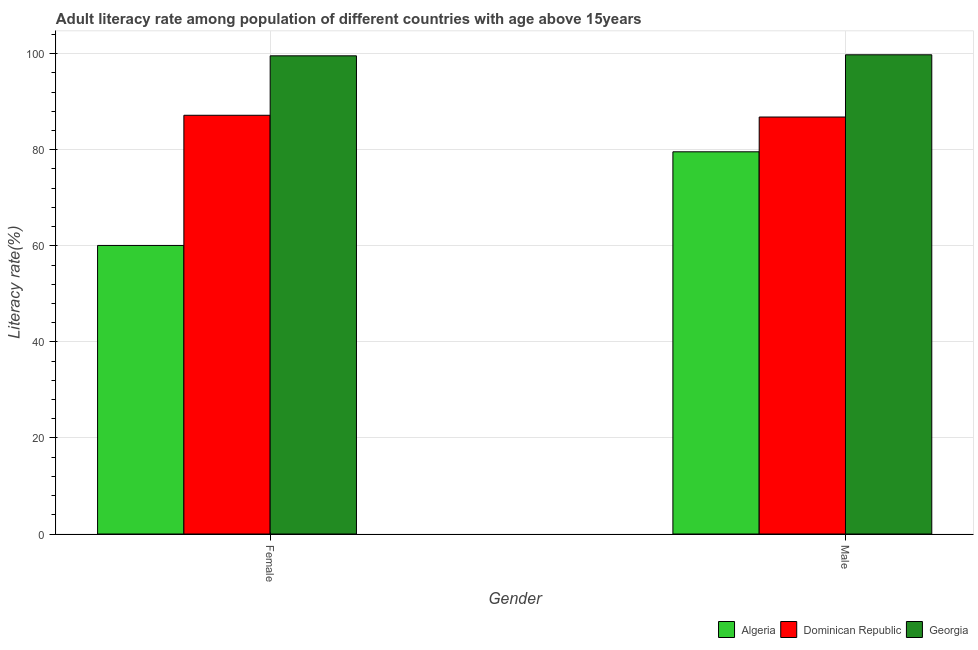How many different coloured bars are there?
Offer a terse response. 3. How many groups of bars are there?
Keep it short and to the point. 2. Are the number of bars per tick equal to the number of legend labels?
Make the answer very short. Yes. How many bars are there on the 2nd tick from the left?
Offer a very short reply. 3. How many bars are there on the 2nd tick from the right?
Keep it short and to the point. 3. What is the label of the 1st group of bars from the left?
Make the answer very short. Female. What is the male adult literacy rate in Algeria?
Make the answer very short. 79.57. Across all countries, what is the maximum female adult literacy rate?
Provide a short and direct response. 99.55. Across all countries, what is the minimum female adult literacy rate?
Your answer should be compact. 60.08. In which country was the female adult literacy rate maximum?
Keep it short and to the point. Georgia. In which country was the male adult literacy rate minimum?
Provide a short and direct response. Algeria. What is the total male adult literacy rate in the graph?
Your response must be concise. 266.15. What is the difference between the female adult literacy rate in Algeria and that in Georgia?
Offer a terse response. -39.48. What is the difference between the female adult literacy rate in Georgia and the male adult literacy rate in Algeria?
Make the answer very short. 19.98. What is the average male adult literacy rate per country?
Keep it short and to the point. 88.72. What is the difference between the male adult literacy rate and female adult literacy rate in Dominican Republic?
Keep it short and to the point. -0.37. In how many countries, is the female adult literacy rate greater than 96 %?
Your answer should be compact. 1. What is the ratio of the female adult literacy rate in Georgia to that in Dominican Republic?
Your answer should be compact. 1.14. In how many countries, is the female adult literacy rate greater than the average female adult literacy rate taken over all countries?
Your answer should be compact. 2. What does the 1st bar from the left in Female represents?
Ensure brevity in your answer.  Algeria. What does the 3rd bar from the right in Male represents?
Ensure brevity in your answer.  Algeria. How many bars are there?
Ensure brevity in your answer.  6. Does the graph contain any zero values?
Provide a succinct answer. No. Does the graph contain grids?
Provide a short and direct response. Yes. Where does the legend appear in the graph?
Your response must be concise. Bottom right. How many legend labels are there?
Keep it short and to the point. 3. What is the title of the graph?
Offer a very short reply. Adult literacy rate among population of different countries with age above 15years. What is the label or title of the X-axis?
Ensure brevity in your answer.  Gender. What is the label or title of the Y-axis?
Ensure brevity in your answer.  Literacy rate(%). What is the Literacy rate(%) of Algeria in Female?
Provide a short and direct response. 60.08. What is the Literacy rate(%) of Dominican Republic in Female?
Provide a succinct answer. 87.18. What is the Literacy rate(%) of Georgia in Female?
Your answer should be very brief. 99.55. What is the Literacy rate(%) of Algeria in Male?
Provide a succinct answer. 79.57. What is the Literacy rate(%) of Dominican Republic in Male?
Your answer should be compact. 86.81. What is the Literacy rate(%) of Georgia in Male?
Provide a succinct answer. 99.77. Across all Gender, what is the maximum Literacy rate(%) in Algeria?
Offer a very short reply. 79.57. Across all Gender, what is the maximum Literacy rate(%) of Dominican Republic?
Your response must be concise. 87.18. Across all Gender, what is the maximum Literacy rate(%) in Georgia?
Offer a terse response. 99.77. Across all Gender, what is the minimum Literacy rate(%) of Algeria?
Give a very brief answer. 60.08. Across all Gender, what is the minimum Literacy rate(%) of Dominican Republic?
Give a very brief answer. 86.81. Across all Gender, what is the minimum Literacy rate(%) of Georgia?
Ensure brevity in your answer.  99.55. What is the total Literacy rate(%) of Algeria in the graph?
Provide a short and direct response. 139.64. What is the total Literacy rate(%) in Dominican Republic in the graph?
Give a very brief answer. 173.99. What is the total Literacy rate(%) in Georgia in the graph?
Offer a very short reply. 199.32. What is the difference between the Literacy rate(%) of Algeria in Female and that in Male?
Provide a short and direct response. -19.49. What is the difference between the Literacy rate(%) of Dominican Republic in Female and that in Male?
Offer a very short reply. 0.37. What is the difference between the Literacy rate(%) of Georgia in Female and that in Male?
Give a very brief answer. -0.22. What is the difference between the Literacy rate(%) in Algeria in Female and the Literacy rate(%) in Dominican Republic in Male?
Keep it short and to the point. -26.74. What is the difference between the Literacy rate(%) in Algeria in Female and the Literacy rate(%) in Georgia in Male?
Provide a short and direct response. -39.69. What is the difference between the Literacy rate(%) in Dominican Republic in Female and the Literacy rate(%) in Georgia in Male?
Offer a terse response. -12.59. What is the average Literacy rate(%) of Algeria per Gender?
Offer a very short reply. 69.82. What is the average Literacy rate(%) of Dominican Republic per Gender?
Your answer should be very brief. 86.99. What is the average Literacy rate(%) of Georgia per Gender?
Provide a short and direct response. 99.66. What is the difference between the Literacy rate(%) in Algeria and Literacy rate(%) in Dominican Republic in Female?
Ensure brevity in your answer.  -27.1. What is the difference between the Literacy rate(%) of Algeria and Literacy rate(%) of Georgia in Female?
Your answer should be very brief. -39.48. What is the difference between the Literacy rate(%) in Dominican Republic and Literacy rate(%) in Georgia in Female?
Keep it short and to the point. -12.38. What is the difference between the Literacy rate(%) of Algeria and Literacy rate(%) of Dominican Republic in Male?
Provide a short and direct response. -7.24. What is the difference between the Literacy rate(%) of Algeria and Literacy rate(%) of Georgia in Male?
Offer a very short reply. -20.2. What is the difference between the Literacy rate(%) of Dominican Republic and Literacy rate(%) of Georgia in Male?
Your response must be concise. -12.96. What is the ratio of the Literacy rate(%) in Algeria in Female to that in Male?
Ensure brevity in your answer.  0.76. What is the ratio of the Literacy rate(%) of Georgia in Female to that in Male?
Your answer should be compact. 1. What is the difference between the highest and the second highest Literacy rate(%) of Algeria?
Offer a terse response. 19.49. What is the difference between the highest and the second highest Literacy rate(%) in Dominican Republic?
Give a very brief answer. 0.37. What is the difference between the highest and the second highest Literacy rate(%) in Georgia?
Make the answer very short. 0.22. What is the difference between the highest and the lowest Literacy rate(%) of Algeria?
Your answer should be compact. 19.49. What is the difference between the highest and the lowest Literacy rate(%) in Dominican Republic?
Keep it short and to the point. 0.37. What is the difference between the highest and the lowest Literacy rate(%) in Georgia?
Provide a short and direct response. 0.22. 